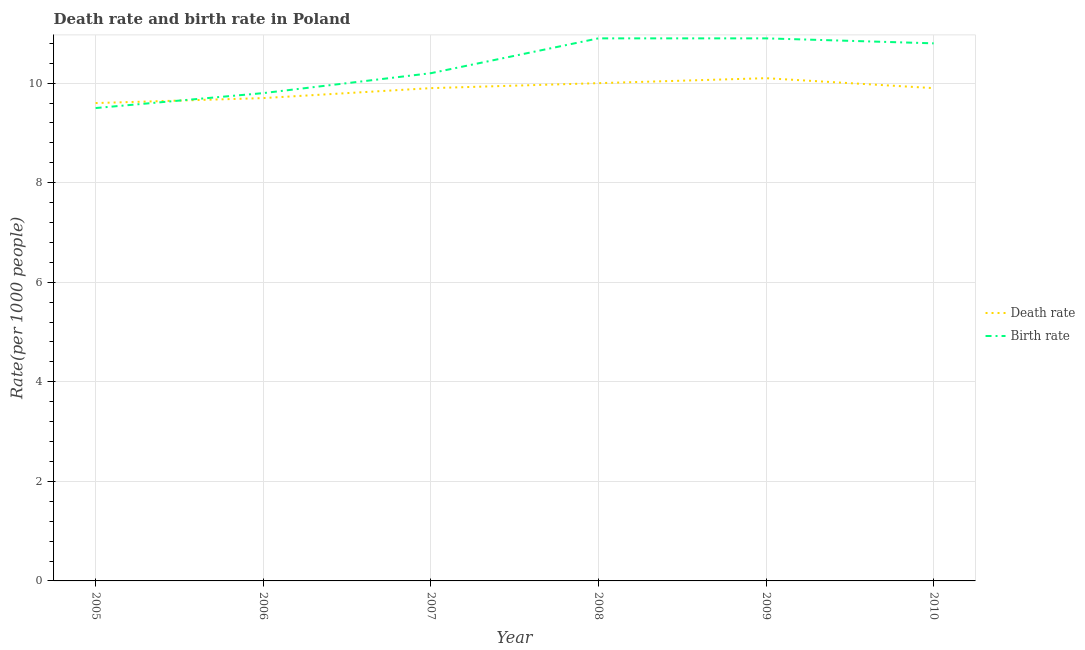Is the number of lines equal to the number of legend labels?
Your response must be concise. Yes. What is the birth rate in 2005?
Offer a very short reply. 9.5. In which year was the birth rate minimum?
Provide a short and direct response. 2005. What is the total death rate in the graph?
Offer a very short reply. 59.2. What is the difference between the death rate in 2005 and that in 2006?
Keep it short and to the point. -0.1. What is the difference between the birth rate in 2010 and the death rate in 2009?
Offer a very short reply. 0.7. What is the average birth rate per year?
Make the answer very short. 10.35. In the year 2010, what is the difference between the birth rate and death rate?
Give a very brief answer. 0.9. In how many years, is the death rate greater than 4?
Provide a succinct answer. 6. What is the ratio of the death rate in 2005 to that in 2010?
Provide a succinct answer. 0.97. Is the difference between the birth rate in 2008 and 2009 greater than the difference between the death rate in 2008 and 2009?
Your answer should be compact. Yes. In how many years, is the birth rate greater than the average birth rate taken over all years?
Provide a succinct answer. 3. Is the sum of the death rate in 2006 and 2009 greater than the maximum birth rate across all years?
Provide a short and direct response. Yes. Is the birth rate strictly greater than the death rate over the years?
Give a very brief answer. No. How many lines are there?
Keep it short and to the point. 2. Are the values on the major ticks of Y-axis written in scientific E-notation?
Your answer should be very brief. No. What is the title of the graph?
Give a very brief answer. Death rate and birth rate in Poland. Does "Mineral" appear as one of the legend labels in the graph?
Offer a terse response. No. What is the label or title of the Y-axis?
Offer a terse response. Rate(per 1000 people). What is the Rate(per 1000 people) of Death rate in 2005?
Your answer should be compact. 9.6. What is the Rate(per 1000 people) of Death rate in 2006?
Make the answer very short. 9.7. What is the Rate(per 1000 people) in Birth rate in 2006?
Provide a short and direct response. 9.8. What is the Rate(per 1000 people) of Death rate in 2007?
Make the answer very short. 9.9. What is the Rate(per 1000 people) of Birth rate in 2007?
Provide a short and direct response. 10.2. What is the Rate(per 1000 people) of Death rate in 2009?
Keep it short and to the point. 10.1. What is the Rate(per 1000 people) of Birth rate in 2009?
Your response must be concise. 10.9. What is the Rate(per 1000 people) of Death rate in 2010?
Provide a short and direct response. 9.9. What is the Rate(per 1000 people) of Birth rate in 2010?
Ensure brevity in your answer.  10.8. Across all years, what is the maximum Rate(per 1000 people) in Birth rate?
Your response must be concise. 10.9. What is the total Rate(per 1000 people) in Death rate in the graph?
Provide a short and direct response. 59.2. What is the total Rate(per 1000 people) of Birth rate in the graph?
Ensure brevity in your answer.  62.1. What is the difference between the Rate(per 1000 people) in Death rate in 2005 and that in 2006?
Provide a succinct answer. -0.1. What is the difference between the Rate(per 1000 people) of Birth rate in 2005 and that in 2006?
Offer a terse response. -0.3. What is the difference between the Rate(per 1000 people) of Birth rate in 2005 and that in 2007?
Your response must be concise. -0.7. What is the difference between the Rate(per 1000 people) of Birth rate in 2005 and that in 2009?
Give a very brief answer. -1.4. What is the difference between the Rate(per 1000 people) in Death rate in 2005 and that in 2010?
Your answer should be compact. -0.3. What is the difference between the Rate(per 1000 people) of Death rate in 2006 and that in 2007?
Provide a short and direct response. -0.2. What is the difference between the Rate(per 1000 people) in Birth rate in 2006 and that in 2007?
Give a very brief answer. -0.4. What is the difference between the Rate(per 1000 people) in Birth rate in 2006 and that in 2008?
Provide a succinct answer. -1.1. What is the difference between the Rate(per 1000 people) of Birth rate in 2006 and that in 2010?
Give a very brief answer. -1. What is the difference between the Rate(per 1000 people) of Death rate in 2007 and that in 2008?
Make the answer very short. -0.1. What is the difference between the Rate(per 1000 people) in Birth rate in 2007 and that in 2008?
Provide a succinct answer. -0.7. What is the difference between the Rate(per 1000 people) in Birth rate in 2007 and that in 2009?
Provide a short and direct response. -0.7. What is the difference between the Rate(per 1000 people) in Birth rate in 2007 and that in 2010?
Provide a succinct answer. -0.6. What is the difference between the Rate(per 1000 people) in Birth rate in 2008 and that in 2009?
Offer a terse response. 0. What is the difference between the Rate(per 1000 people) in Birth rate in 2008 and that in 2010?
Provide a short and direct response. 0.1. What is the difference between the Rate(per 1000 people) in Death rate in 2009 and that in 2010?
Give a very brief answer. 0.2. What is the difference between the Rate(per 1000 people) of Birth rate in 2009 and that in 2010?
Offer a very short reply. 0.1. What is the difference between the Rate(per 1000 people) of Death rate in 2005 and the Rate(per 1000 people) of Birth rate in 2007?
Provide a succinct answer. -0.6. What is the difference between the Rate(per 1000 people) in Death rate in 2005 and the Rate(per 1000 people) in Birth rate in 2008?
Ensure brevity in your answer.  -1.3. What is the difference between the Rate(per 1000 people) of Death rate in 2006 and the Rate(per 1000 people) of Birth rate in 2008?
Offer a very short reply. -1.2. What is the difference between the Rate(per 1000 people) of Death rate in 2006 and the Rate(per 1000 people) of Birth rate in 2009?
Your response must be concise. -1.2. What is the difference between the Rate(per 1000 people) of Death rate in 2007 and the Rate(per 1000 people) of Birth rate in 2010?
Your answer should be compact. -0.9. What is the difference between the Rate(per 1000 people) of Death rate in 2008 and the Rate(per 1000 people) of Birth rate in 2009?
Make the answer very short. -0.9. What is the difference between the Rate(per 1000 people) of Death rate in 2008 and the Rate(per 1000 people) of Birth rate in 2010?
Offer a terse response. -0.8. What is the difference between the Rate(per 1000 people) in Death rate in 2009 and the Rate(per 1000 people) in Birth rate in 2010?
Ensure brevity in your answer.  -0.7. What is the average Rate(per 1000 people) of Death rate per year?
Your response must be concise. 9.87. What is the average Rate(per 1000 people) of Birth rate per year?
Your answer should be compact. 10.35. In the year 2005, what is the difference between the Rate(per 1000 people) of Death rate and Rate(per 1000 people) of Birth rate?
Your answer should be very brief. 0.1. In the year 2008, what is the difference between the Rate(per 1000 people) of Death rate and Rate(per 1000 people) of Birth rate?
Offer a very short reply. -0.9. In the year 2010, what is the difference between the Rate(per 1000 people) in Death rate and Rate(per 1000 people) in Birth rate?
Your answer should be very brief. -0.9. What is the ratio of the Rate(per 1000 people) in Death rate in 2005 to that in 2006?
Your response must be concise. 0.99. What is the ratio of the Rate(per 1000 people) of Birth rate in 2005 to that in 2006?
Keep it short and to the point. 0.97. What is the ratio of the Rate(per 1000 people) of Death rate in 2005 to that in 2007?
Make the answer very short. 0.97. What is the ratio of the Rate(per 1000 people) in Birth rate in 2005 to that in 2007?
Ensure brevity in your answer.  0.93. What is the ratio of the Rate(per 1000 people) of Death rate in 2005 to that in 2008?
Your answer should be very brief. 0.96. What is the ratio of the Rate(per 1000 people) in Birth rate in 2005 to that in 2008?
Your response must be concise. 0.87. What is the ratio of the Rate(per 1000 people) in Death rate in 2005 to that in 2009?
Provide a succinct answer. 0.95. What is the ratio of the Rate(per 1000 people) of Birth rate in 2005 to that in 2009?
Your response must be concise. 0.87. What is the ratio of the Rate(per 1000 people) in Death rate in 2005 to that in 2010?
Keep it short and to the point. 0.97. What is the ratio of the Rate(per 1000 people) in Birth rate in 2005 to that in 2010?
Your answer should be very brief. 0.88. What is the ratio of the Rate(per 1000 people) in Death rate in 2006 to that in 2007?
Give a very brief answer. 0.98. What is the ratio of the Rate(per 1000 people) of Birth rate in 2006 to that in 2007?
Give a very brief answer. 0.96. What is the ratio of the Rate(per 1000 people) in Death rate in 2006 to that in 2008?
Make the answer very short. 0.97. What is the ratio of the Rate(per 1000 people) of Birth rate in 2006 to that in 2008?
Your answer should be compact. 0.9. What is the ratio of the Rate(per 1000 people) of Death rate in 2006 to that in 2009?
Your answer should be compact. 0.96. What is the ratio of the Rate(per 1000 people) in Birth rate in 2006 to that in 2009?
Your answer should be very brief. 0.9. What is the ratio of the Rate(per 1000 people) in Death rate in 2006 to that in 2010?
Give a very brief answer. 0.98. What is the ratio of the Rate(per 1000 people) of Birth rate in 2006 to that in 2010?
Provide a short and direct response. 0.91. What is the ratio of the Rate(per 1000 people) in Birth rate in 2007 to that in 2008?
Provide a short and direct response. 0.94. What is the ratio of the Rate(per 1000 people) of Death rate in 2007 to that in 2009?
Your answer should be compact. 0.98. What is the ratio of the Rate(per 1000 people) in Birth rate in 2007 to that in 2009?
Keep it short and to the point. 0.94. What is the ratio of the Rate(per 1000 people) in Death rate in 2008 to that in 2009?
Your response must be concise. 0.99. What is the ratio of the Rate(per 1000 people) of Birth rate in 2008 to that in 2010?
Offer a very short reply. 1.01. What is the ratio of the Rate(per 1000 people) in Death rate in 2009 to that in 2010?
Your answer should be compact. 1.02. What is the ratio of the Rate(per 1000 people) of Birth rate in 2009 to that in 2010?
Provide a short and direct response. 1.01. What is the difference between the highest and the second highest Rate(per 1000 people) in Death rate?
Keep it short and to the point. 0.1. 